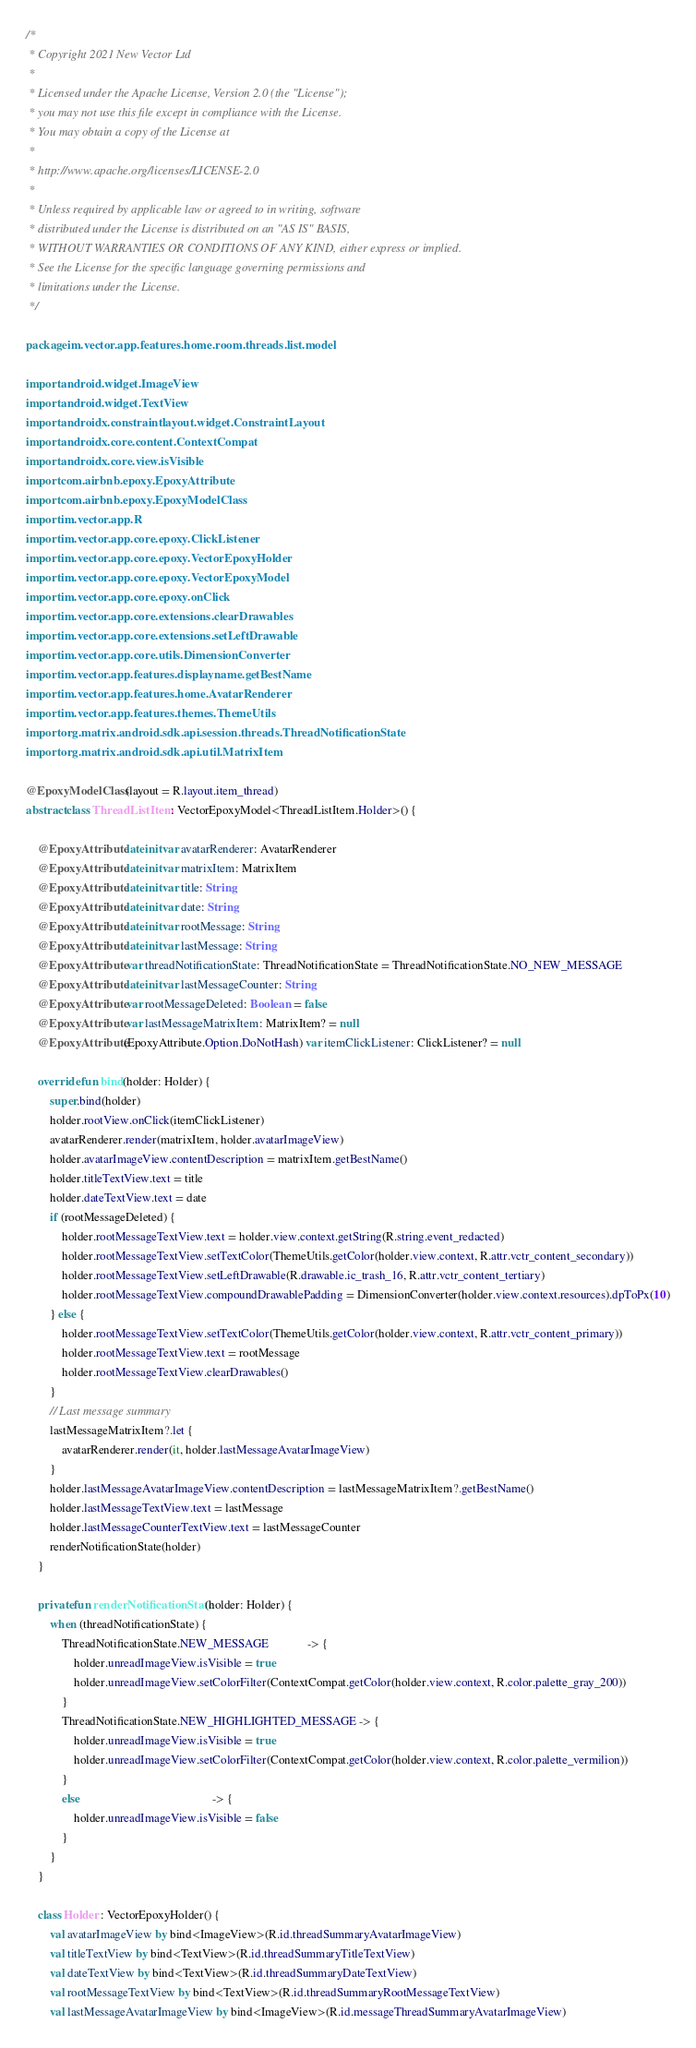<code> <loc_0><loc_0><loc_500><loc_500><_Kotlin_>/*
 * Copyright 2021 New Vector Ltd
 *
 * Licensed under the Apache License, Version 2.0 (the "License");
 * you may not use this file except in compliance with the License.
 * You may obtain a copy of the License at
 *
 * http://www.apache.org/licenses/LICENSE-2.0
 *
 * Unless required by applicable law or agreed to in writing, software
 * distributed under the License is distributed on an "AS IS" BASIS,
 * WITHOUT WARRANTIES OR CONDITIONS OF ANY KIND, either express or implied.
 * See the License for the specific language governing permissions and
 * limitations under the License.
 */

package im.vector.app.features.home.room.threads.list.model

import android.widget.ImageView
import android.widget.TextView
import androidx.constraintlayout.widget.ConstraintLayout
import androidx.core.content.ContextCompat
import androidx.core.view.isVisible
import com.airbnb.epoxy.EpoxyAttribute
import com.airbnb.epoxy.EpoxyModelClass
import im.vector.app.R
import im.vector.app.core.epoxy.ClickListener
import im.vector.app.core.epoxy.VectorEpoxyHolder
import im.vector.app.core.epoxy.VectorEpoxyModel
import im.vector.app.core.epoxy.onClick
import im.vector.app.core.extensions.clearDrawables
import im.vector.app.core.extensions.setLeftDrawable
import im.vector.app.core.utils.DimensionConverter
import im.vector.app.features.displayname.getBestName
import im.vector.app.features.home.AvatarRenderer
import im.vector.app.features.themes.ThemeUtils
import org.matrix.android.sdk.api.session.threads.ThreadNotificationState
import org.matrix.android.sdk.api.util.MatrixItem

@EpoxyModelClass(layout = R.layout.item_thread)
abstract class ThreadListItem : VectorEpoxyModel<ThreadListItem.Holder>() {

    @EpoxyAttribute lateinit var avatarRenderer: AvatarRenderer
    @EpoxyAttribute lateinit var matrixItem: MatrixItem
    @EpoxyAttribute lateinit var title: String
    @EpoxyAttribute lateinit var date: String
    @EpoxyAttribute lateinit var rootMessage: String
    @EpoxyAttribute lateinit var lastMessage: String
    @EpoxyAttribute var threadNotificationState: ThreadNotificationState = ThreadNotificationState.NO_NEW_MESSAGE
    @EpoxyAttribute lateinit var lastMessageCounter: String
    @EpoxyAttribute var rootMessageDeleted: Boolean = false
    @EpoxyAttribute var lastMessageMatrixItem: MatrixItem? = null
    @EpoxyAttribute(EpoxyAttribute.Option.DoNotHash) var itemClickListener: ClickListener? = null

    override fun bind(holder: Holder) {
        super.bind(holder)
        holder.rootView.onClick(itemClickListener)
        avatarRenderer.render(matrixItem, holder.avatarImageView)
        holder.avatarImageView.contentDescription = matrixItem.getBestName()
        holder.titleTextView.text = title
        holder.dateTextView.text = date
        if (rootMessageDeleted) {
            holder.rootMessageTextView.text = holder.view.context.getString(R.string.event_redacted)
            holder.rootMessageTextView.setTextColor(ThemeUtils.getColor(holder.view.context, R.attr.vctr_content_secondary))
            holder.rootMessageTextView.setLeftDrawable(R.drawable.ic_trash_16, R.attr.vctr_content_tertiary)
            holder.rootMessageTextView.compoundDrawablePadding = DimensionConverter(holder.view.context.resources).dpToPx(10)
        } else {
            holder.rootMessageTextView.setTextColor(ThemeUtils.getColor(holder.view.context, R.attr.vctr_content_primary))
            holder.rootMessageTextView.text = rootMessage
            holder.rootMessageTextView.clearDrawables()
        }
        // Last message summary
        lastMessageMatrixItem?.let {
            avatarRenderer.render(it, holder.lastMessageAvatarImageView)
        }
        holder.lastMessageAvatarImageView.contentDescription = lastMessageMatrixItem?.getBestName()
        holder.lastMessageTextView.text = lastMessage
        holder.lastMessageCounterTextView.text = lastMessageCounter
        renderNotificationState(holder)
    }

    private fun renderNotificationState(holder: Holder) {
        when (threadNotificationState) {
            ThreadNotificationState.NEW_MESSAGE             -> {
                holder.unreadImageView.isVisible = true
                holder.unreadImageView.setColorFilter(ContextCompat.getColor(holder.view.context, R.color.palette_gray_200))
            }
            ThreadNotificationState.NEW_HIGHLIGHTED_MESSAGE -> {
                holder.unreadImageView.isVisible = true
                holder.unreadImageView.setColorFilter(ContextCompat.getColor(holder.view.context, R.color.palette_vermilion))
            }
            else                                            -> {
                holder.unreadImageView.isVisible = false
            }
        }
    }

    class Holder : VectorEpoxyHolder() {
        val avatarImageView by bind<ImageView>(R.id.threadSummaryAvatarImageView)
        val titleTextView by bind<TextView>(R.id.threadSummaryTitleTextView)
        val dateTextView by bind<TextView>(R.id.threadSummaryDateTextView)
        val rootMessageTextView by bind<TextView>(R.id.threadSummaryRootMessageTextView)
        val lastMessageAvatarImageView by bind<ImageView>(R.id.messageThreadSummaryAvatarImageView)</code> 